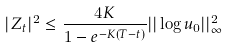<formula> <loc_0><loc_0><loc_500><loc_500>| Z _ { t } | ^ { 2 } \leq \frac { 4 K } { 1 - e ^ { - K ( T - t ) } } | | \log u _ { 0 } | | _ { \infty } ^ { 2 }</formula> 